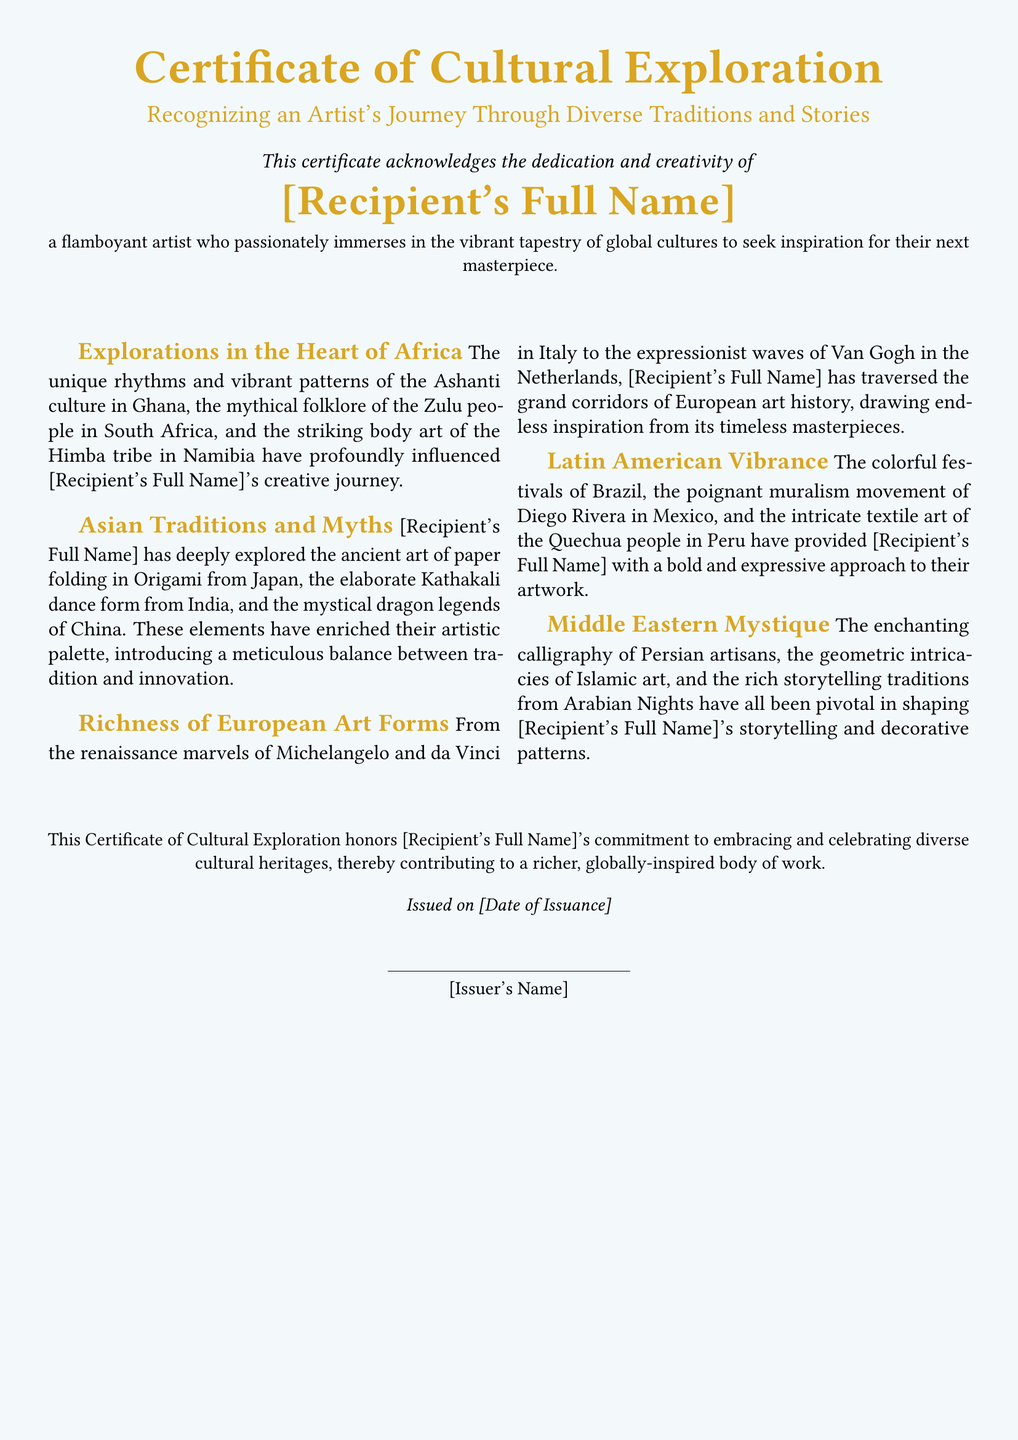What is the title of the certificate? The title of the certificate is prominently displayed at the top and reads, "Certificate of Cultural Exploration."
Answer: Certificate of Cultural Exploration Who is the certificate issued to? The recipient's name is mentioned in a highlighted format, clearly identifying the individual recognized by this certificate.
Answer: [Recipient's Full Name] What cultural heritage is explored in the heart of which continent? The section titled "Explorations in the Heart of Africa" specifies the continent linked to this cultural exploration.
Answer: Africa Which dance form from India is mentioned in the document? The document lists specific cultural elements, including the dance form associated with Indian traditions.
Answer: Kathakali What artistic medium is noted in Middle Eastern traditions? The document highlights specific art forms, including one that showcases intricate designs often seen in this region.
Answer: Calligraphy When was the certificate issued? The certificate includes an issuance date within a standard text section, indicating when the recognition was granted.
Answer: [Date of Issuance] What is the color of the background in the certificate? The background color is described at the beginning of the document, setting a tone for the presentation.
Answer: Pale blue What element of European culture does the document reference for inspiration? The document draws specific references to significant artistic movements and figures within European history.
Answer: Renaissance How does the certificate describe the artist's commitment? The document concludes with a statement recognizing the dedication and contributions made by the artist in embracing diversity.
Answer: Commitment to embracing and celebrating diverse cultural heritages 